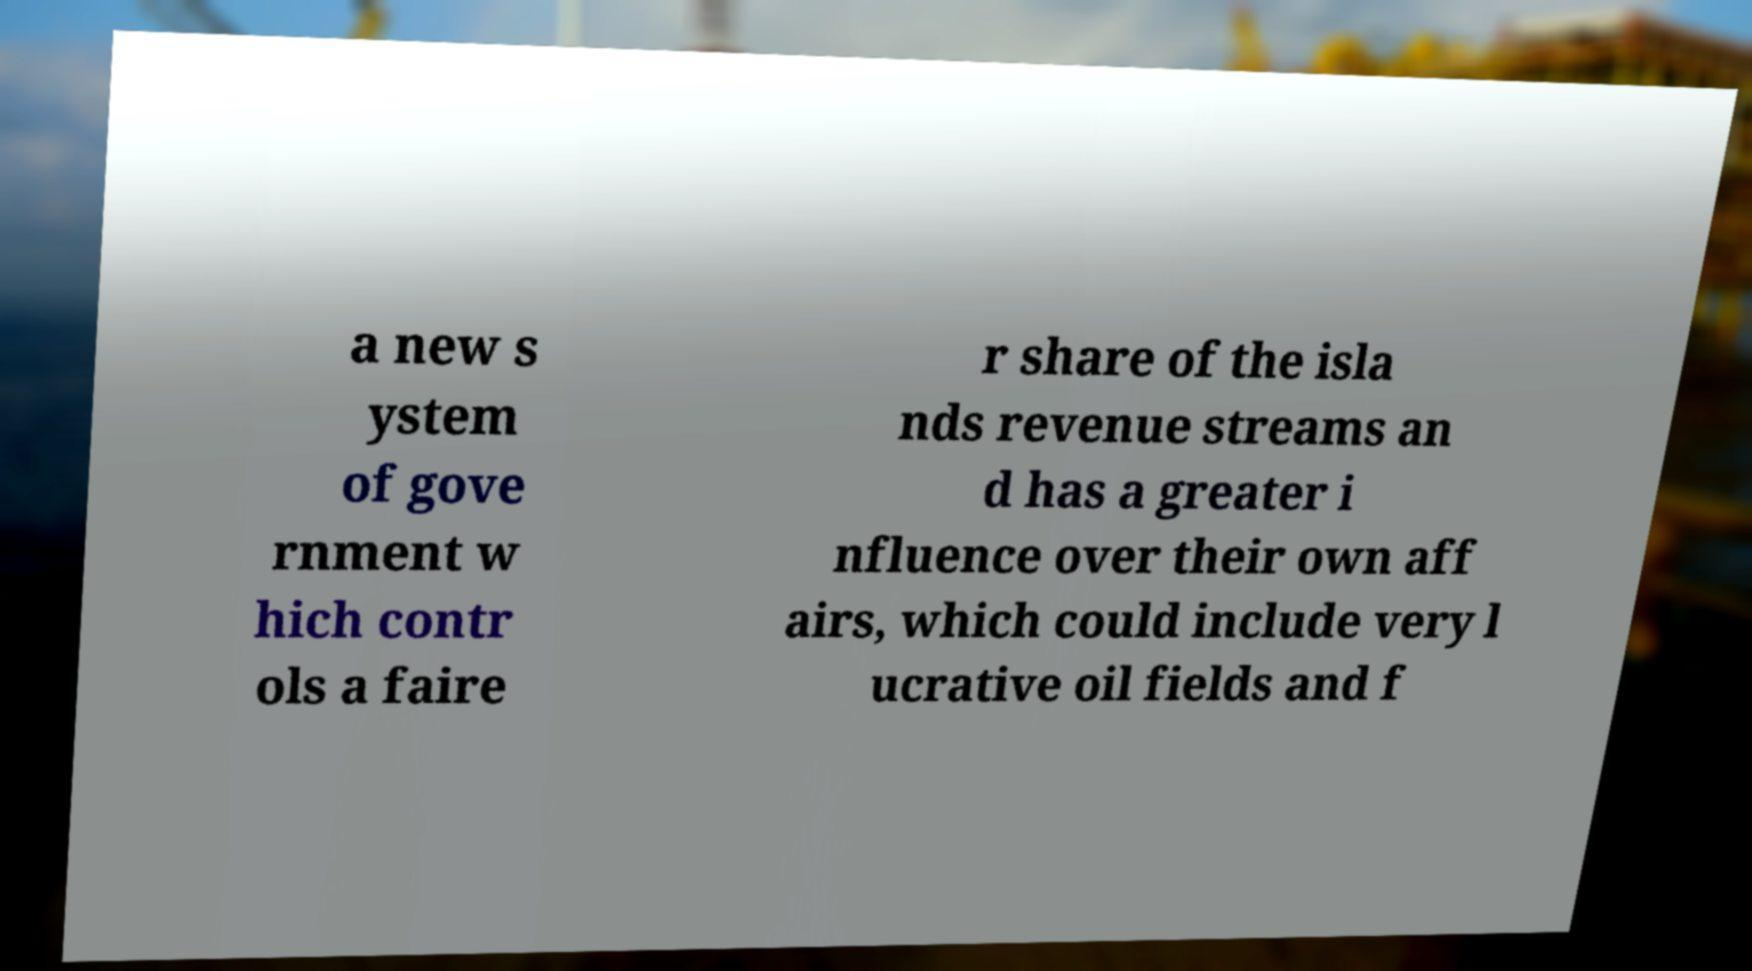For documentation purposes, I need the text within this image transcribed. Could you provide that? a new s ystem of gove rnment w hich contr ols a faire r share of the isla nds revenue streams an d has a greater i nfluence over their own aff airs, which could include very l ucrative oil fields and f 